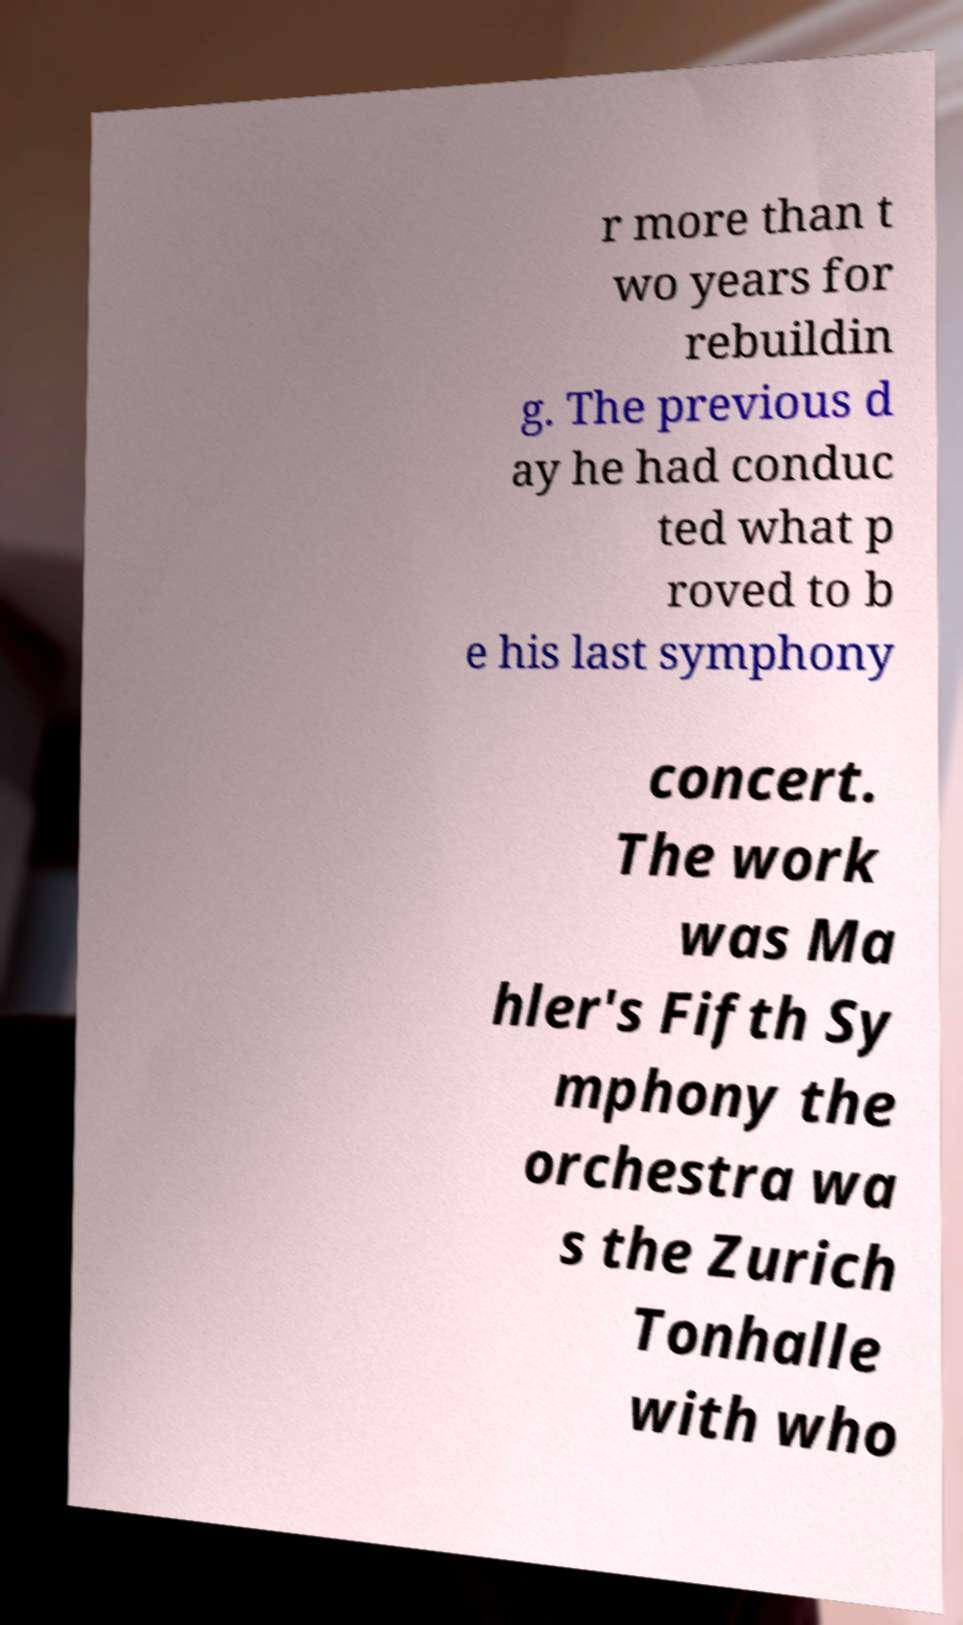Can you read and provide the text displayed in the image?This photo seems to have some interesting text. Can you extract and type it out for me? r more than t wo years for rebuildin g. The previous d ay he had conduc ted what p roved to b e his last symphony concert. The work was Ma hler's Fifth Sy mphony the orchestra wa s the Zurich Tonhalle with who 